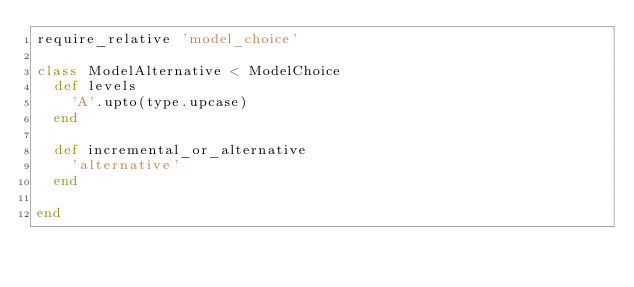Convert code to text. <code><loc_0><loc_0><loc_500><loc_500><_Ruby_>require_relative 'model_choice'

class ModelAlternative < ModelChoice
  def levels
    'A'.upto(type.upcase)
  end

  def incremental_or_alternative
    'alternative'
  end

end</code> 